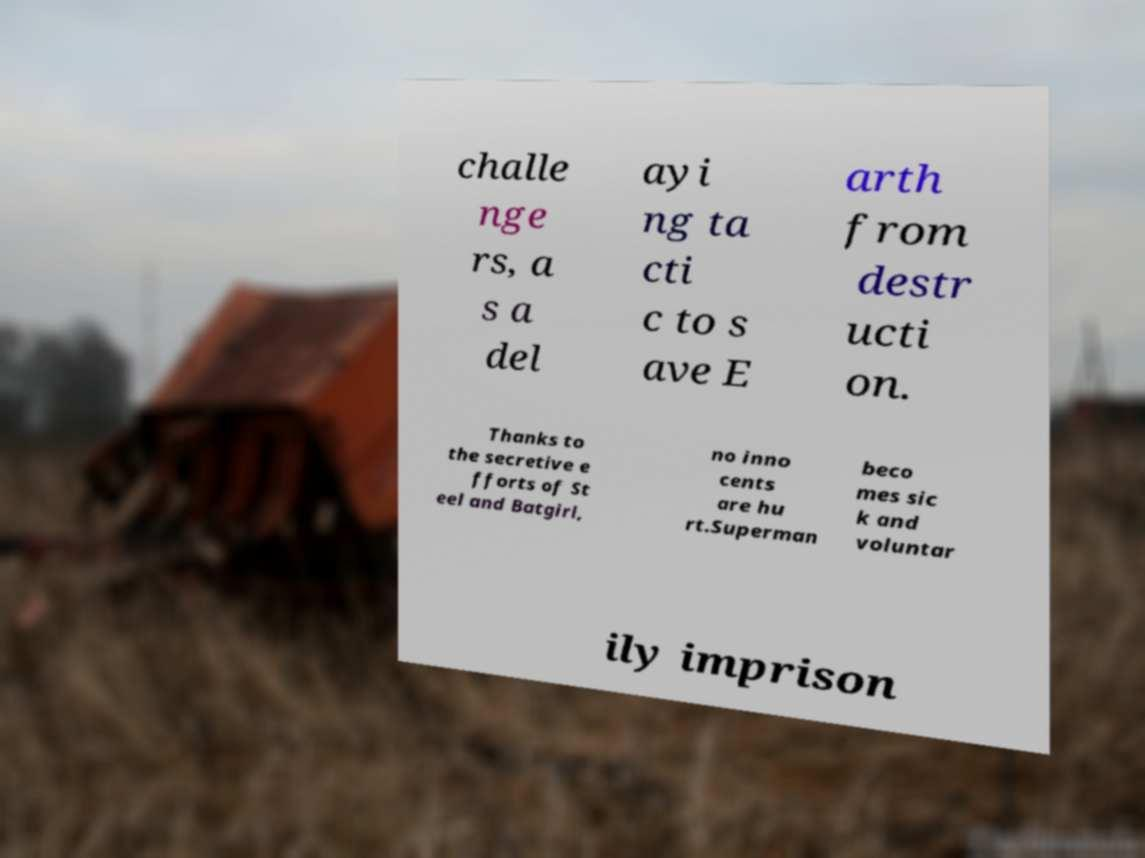Could you extract and type out the text from this image? challe nge rs, a s a del ayi ng ta cti c to s ave E arth from destr ucti on. Thanks to the secretive e fforts of St eel and Batgirl, no inno cents are hu rt.Superman beco mes sic k and voluntar ily imprison 